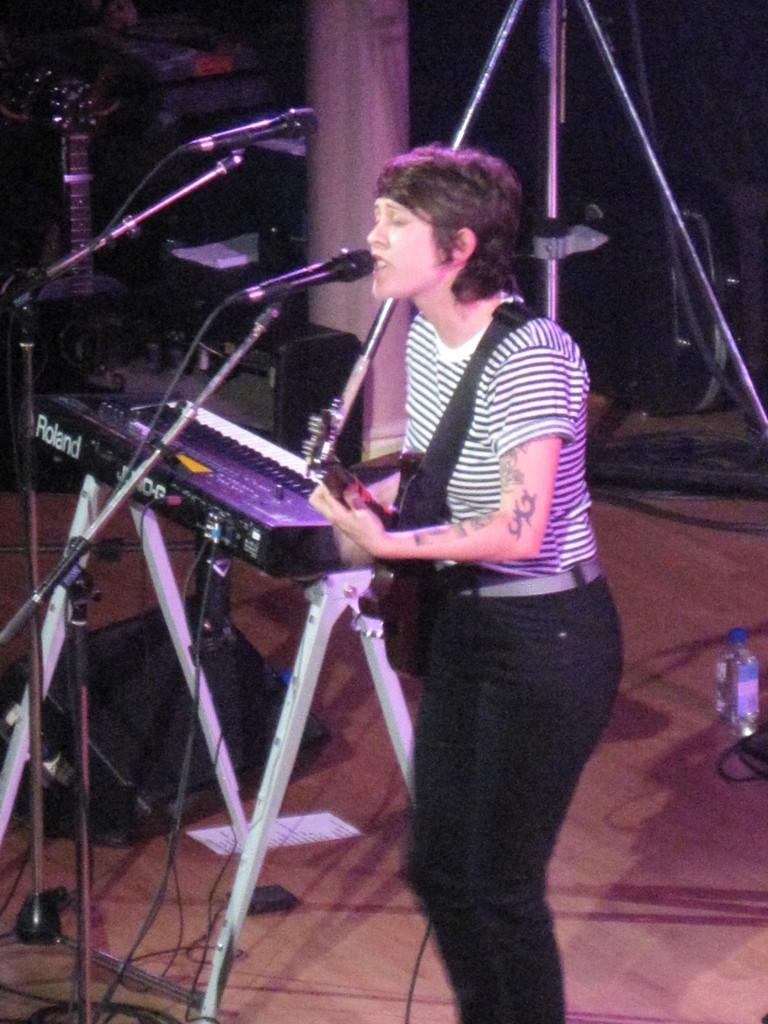Who is the main subject in the image? There is a woman in the image. What is the woman doing in the image? The woman is singing a song. What instrument is the woman holding in the image? The woman is holding a guitar. What other musical instrument can be seen in the image? There is a piano in the image. Can you describe the background of the image? There are musical instruments in the background of the image. What type of liquid is being poured onto the piano in the image? There is no liquid being poured onto the piano in the image. What kind of destruction can be seen happening to the guitar in the image? There is no destruction happening to the guitar in the image; it is being held by the woman. 